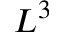<formula> <loc_0><loc_0><loc_500><loc_500>L ^ { 3 }</formula> 